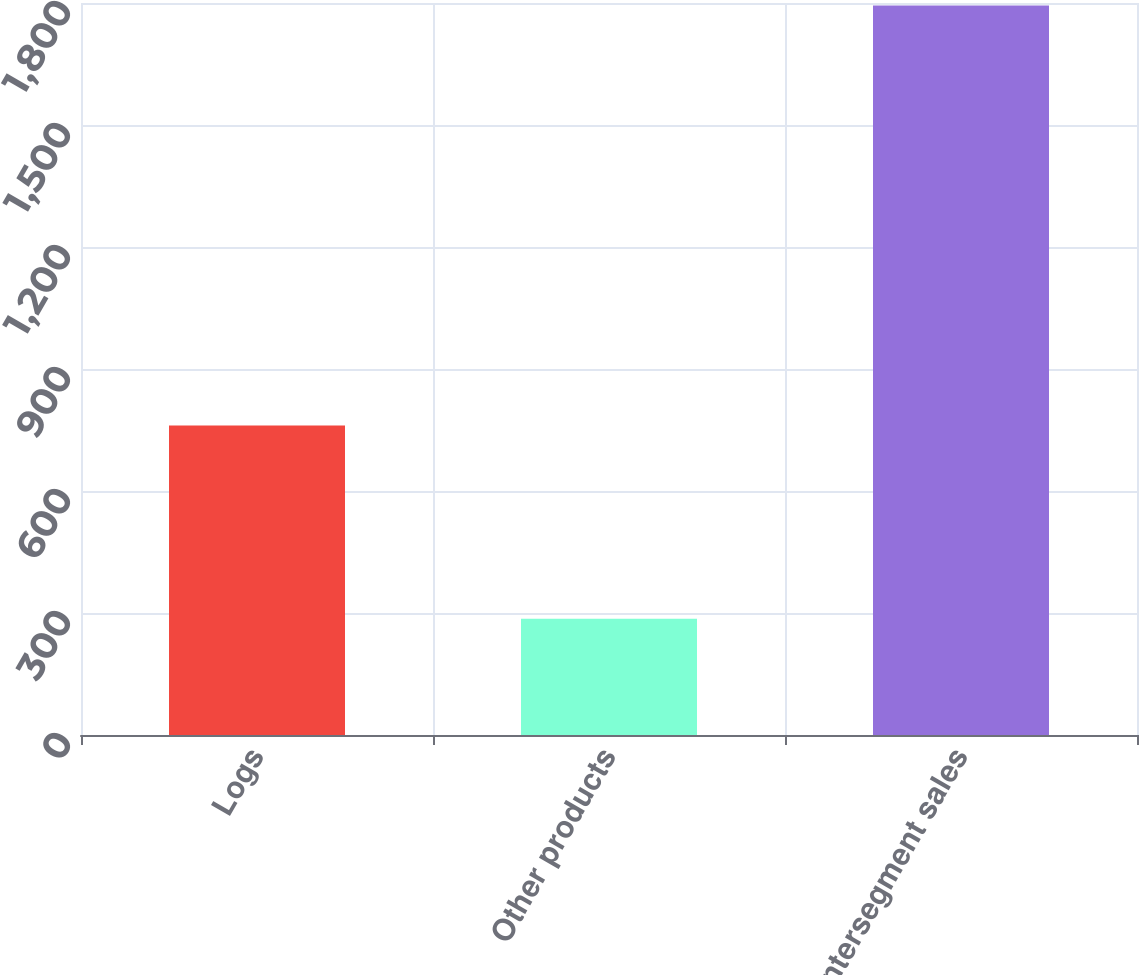Convert chart. <chart><loc_0><loc_0><loc_500><loc_500><bar_chart><fcel>Logs<fcel>Other products<fcel>Intersegment sales<nl><fcel>761<fcel>286<fcel>1794<nl></chart> 